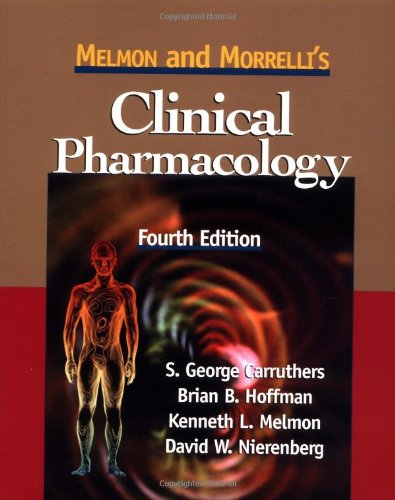What is the genre of this book? The genre of 'Melmon and Morrelli's Clinical Pharmacology' is medical literature, focusing on pharmacology which deals with the study of drug action. 